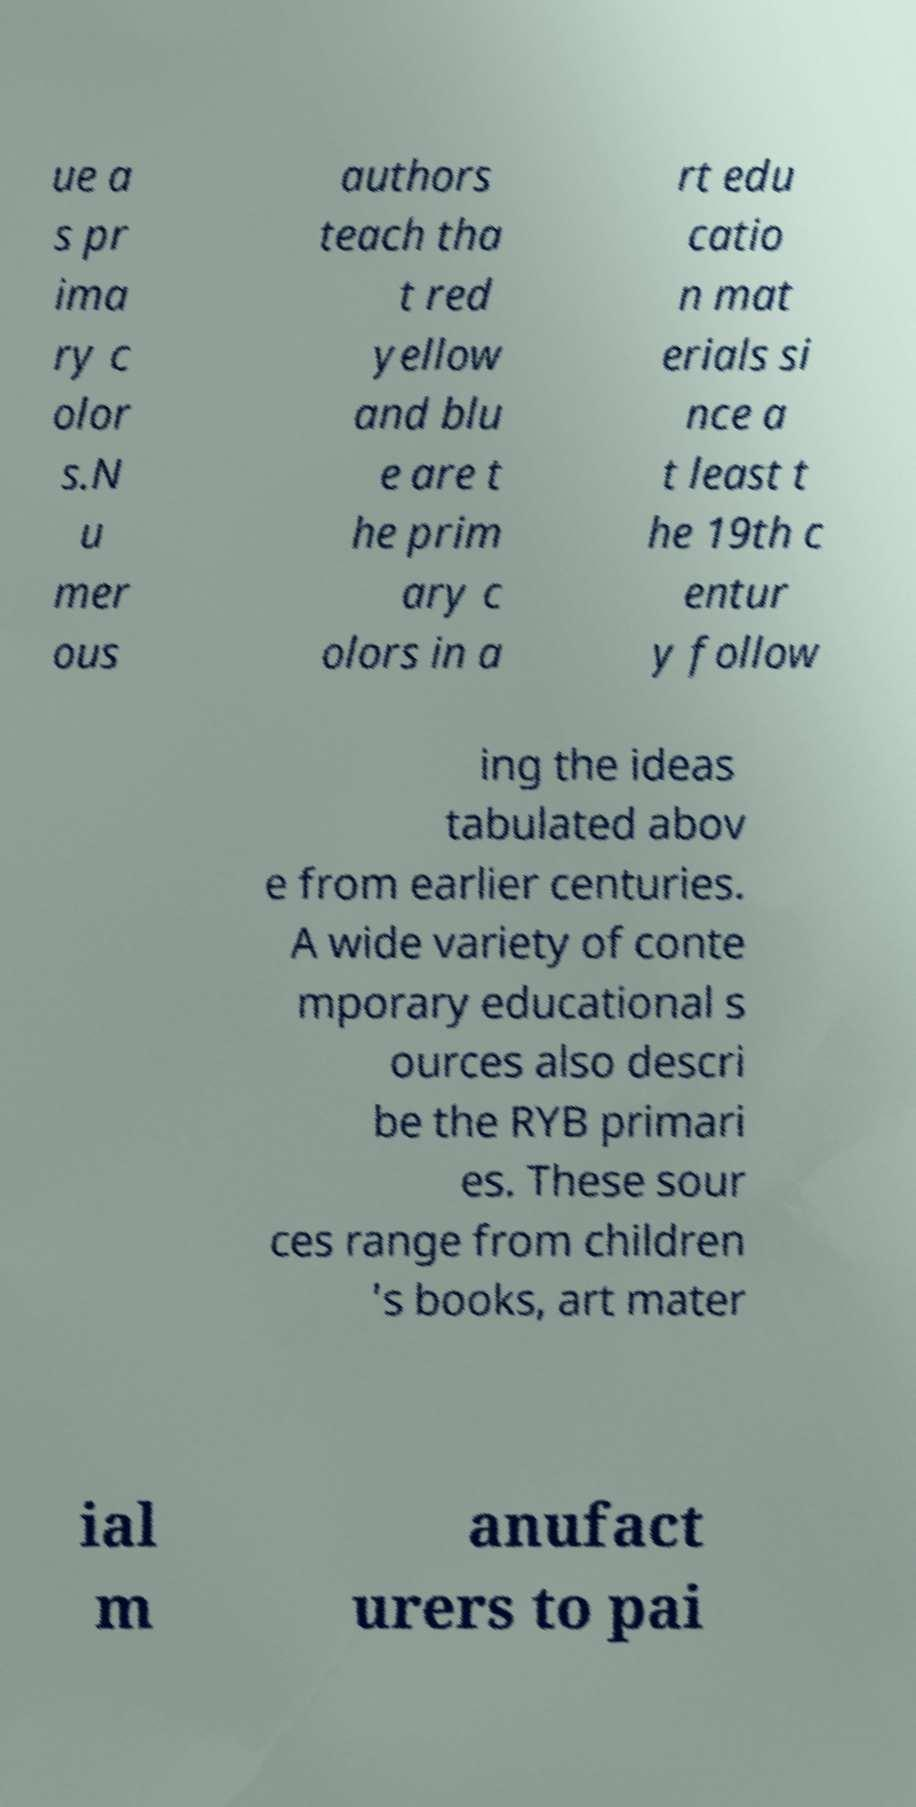Can you read and provide the text displayed in the image?This photo seems to have some interesting text. Can you extract and type it out for me? ue a s pr ima ry c olor s.N u mer ous authors teach tha t red yellow and blu e are t he prim ary c olors in a rt edu catio n mat erials si nce a t least t he 19th c entur y follow ing the ideas tabulated abov e from earlier centuries. A wide variety of conte mporary educational s ources also descri be the RYB primari es. These sour ces range from children 's books, art mater ial m anufact urers to pai 